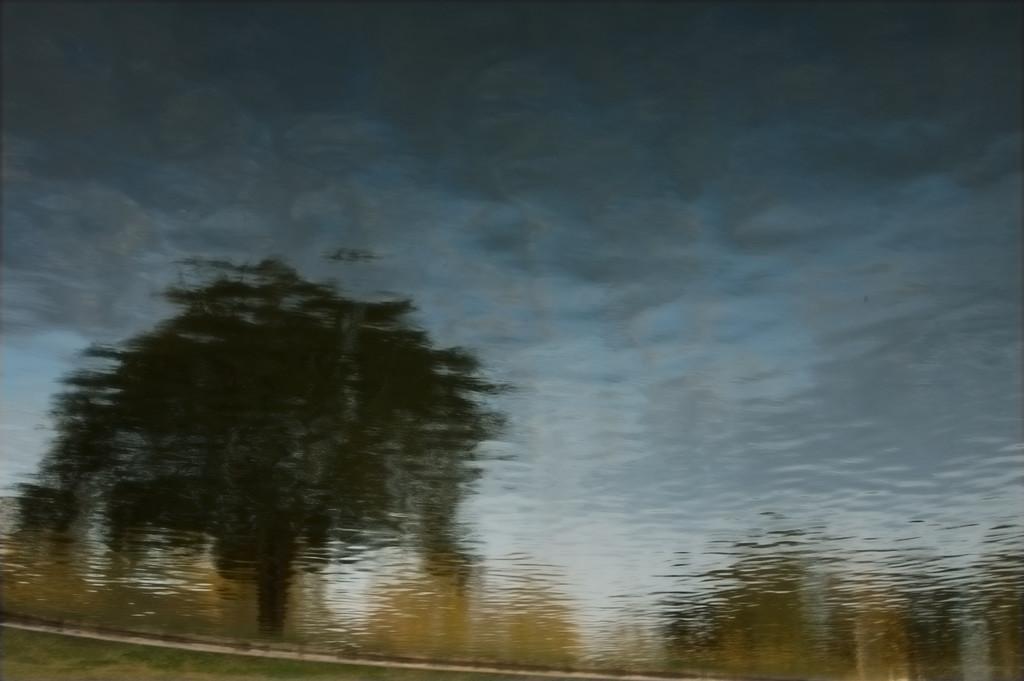Can you describe this image briefly? In this picture there is a tree and there are plants. At the top there is sky and the image is blurry. 